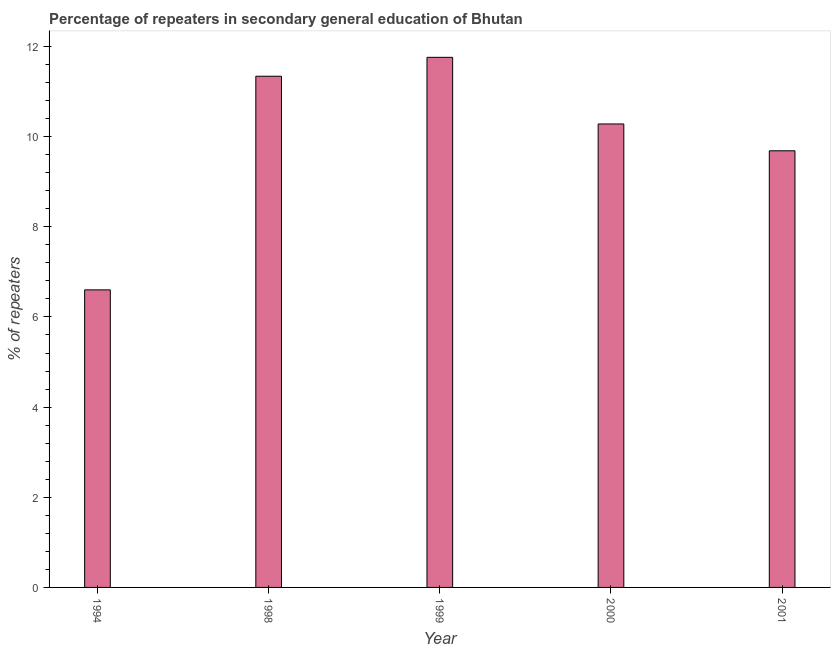Does the graph contain any zero values?
Your response must be concise. No. What is the title of the graph?
Your response must be concise. Percentage of repeaters in secondary general education of Bhutan. What is the label or title of the Y-axis?
Provide a succinct answer. % of repeaters. What is the percentage of repeaters in 1998?
Your answer should be very brief. 11.34. Across all years, what is the maximum percentage of repeaters?
Offer a very short reply. 11.76. Across all years, what is the minimum percentage of repeaters?
Your response must be concise. 6.6. In which year was the percentage of repeaters maximum?
Offer a terse response. 1999. In which year was the percentage of repeaters minimum?
Your response must be concise. 1994. What is the sum of the percentage of repeaters?
Provide a short and direct response. 49.67. What is the difference between the percentage of repeaters in 1994 and 1998?
Your answer should be very brief. -4.74. What is the average percentage of repeaters per year?
Your response must be concise. 9.93. What is the median percentage of repeaters?
Your response must be concise. 10.28. What is the ratio of the percentage of repeaters in 1994 to that in 2001?
Provide a short and direct response. 0.68. Is the difference between the percentage of repeaters in 2000 and 2001 greater than the difference between any two years?
Your response must be concise. No. What is the difference between the highest and the second highest percentage of repeaters?
Keep it short and to the point. 0.42. What is the difference between the highest and the lowest percentage of repeaters?
Make the answer very short. 5.16. In how many years, is the percentage of repeaters greater than the average percentage of repeaters taken over all years?
Your answer should be very brief. 3. Are all the bars in the graph horizontal?
Provide a succinct answer. No. What is the difference between two consecutive major ticks on the Y-axis?
Offer a very short reply. 2. What is the % of repeaters of 1994?
Offer a terse response. 6.6. What is the % of repeaters in 1998?
Provide a short and direct response. 11.34. What is the % of repeaters of 1999?
Provide a succinct answer. 11.76. What is the % of repeaters in 2000?
Your response must be concise. 10.28. What is the % of repeaters in 2001?
Provide a short and direct response. 9.69. What is the difference between the % of repeaters in 1994 and 1998?
Your answer should be very brief. -4.74. What is the difference between the % of repeaters in 1994 and 1999?
Provide a succinct answer. -5.16. What is the difference between the % of repeaters in 1994 and 2000?
Provide a succinct answer. -3.68. What is the difference between the % of repeaters in 1994 and 2001?
Provide a short and direct response. -3.09. What is the difference between the % of repeaters in 1998 and 1999?
Your response must be concise. -0.42. What is the difference between the % of repeaters in 1998 and 2000?
Ensure brevity in your answer.  1.06. What is the difference between the % of repeaters in 1998 and 2001?
Your answer should be compact. 1.65. What is the difference between the % of repeaters in 1999 and 2000?
Provide a succinct answer. 1.48. What is the difference between the % of repeaters in 1999 and 2001?
Provide a succinct answer. 2.07. What is the difference between the % of repeaters in 2000 and 2001?
Offer a terse response. 0.6. What is the ratio of the % of repeaters in 1994 to that in 1998?
Provide a succinct answer. 0.58. What is the ratio of the % of repeaters in 1994 to that in 1999?
Offer a very short reply. 0.56. What is the ratio of the % of repeaters in 1994 to that in 2000?
Ensure brevity in your answer.  0.64. What is the ratio of the % of repeaters in 1994 to that in 2001?
Offer a terse response. 0.68. What is the ratio of the % of repeaters in 1998 to that in 1999?
Provide a short and direct response. 0.96. What is the ratio of the % of repeaters in 1998 to that in 2000?
Offer a very short reply. 1.1. What is the ratio of the % of repeaters in 1998 to that in 2001?
Your response must be concise. 1.17. What is the ratio of the % of repeaters in 1999 to that in 2000?
Provide a short and direct response. 1.14. What is the ratio of the % of repeaters in 1999 to that in 2001?
Ensure brevity in your answer.  1.21. What is the ratio of the % of repeaters in 2000 to that in 2001?
Keep it short and to the point. 1.06. 